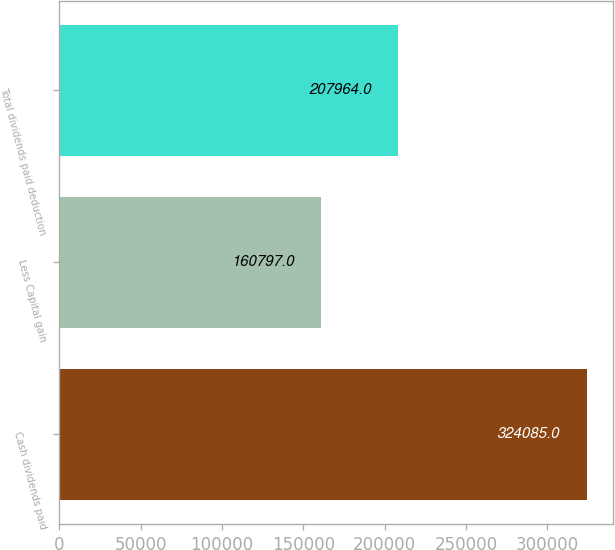Convert chart. <chart><loc_0><loc_0><loc_500><loc_500><bar_chart><fcel>Cash dividends paid<fcel>Less Capital gain<fcel>Total dividends paid deduction<nl><fcel>324085<fcel>160797<fcel>207964<nl></chart> 